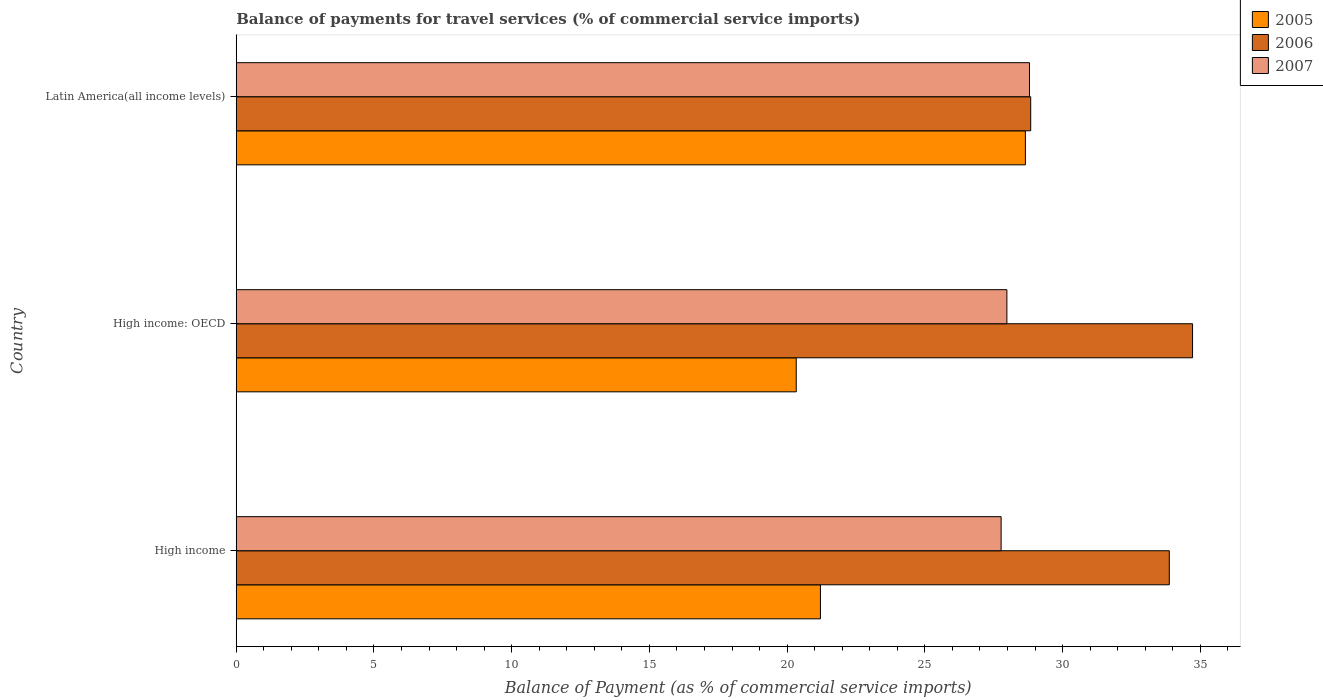How many different coloured bars are there?
Give a very brief answer. 3. How many bars are there on the 3rd tick from the top?
Offer a terse response. 3. How many bars are there on the 3rd tick from the bottom?
Offer a very short reply. 3. What is the label of the 1st group of bars from the top?
Offer a terse response. Latin America(all income levels). What is the balance of payments for travel services in 2006 in High income: OECD?
Ensure brevity in your answer.  34.72. Across all countries, what is the maximum balance of payments for travel services in 2007?
Your answer should be compact. 28.8. Across all countries, what is the minimum balance of payments for travel services in 2007?
Give a very brief answer. 27.77. In which country was the balance of payments for travel services in 2007 maximum?
Your answer should be very brief. Latin America(all income levels). In which country was the balance of payments for travel services in 2007 minimum?
Keep it short and to the point. High income. What is the total balance of payments for travel services in 2007 in the graph?
Keep it short and to the point. 84.55. What is the difference between the balance of payments for travel services in 2007 in High income: OECD and that in Latin America(all income levels)?
Provide a succinct answer. -0.82. What is the difference between the balance of payments for travel services in 2006 in High income and the balance of payments for travel services in 2005 in Latin America(all income levels)?
Keep it short and to the point. 5.23. What is the average balance of payments for travel services in 2006 per country?
Make the answer very short. 32.48. What is the difference between the balance of payments for travel services in 2005 and balance of payments for travel services in 2006 in High income?
Make the answer very short. -12.67. What is the ratio of the balance of payments for travel services in 2005 in High income: OECD to that in Latin America(all income levels)?
Offer a very short reply. 0.71. Is the difference between the balance of payments for travel services in 2005 in High income and Latin America(all income levels) greater than the difference between the balance of payments for travel services in 2006 in High income and Latin America(all income levels)?
Give a very brief answer. No. What is the difference between the highest and the second highest balance of payments for travel services in 2006?
Your response must be concise. 0.84. What is the difference between the highest and the lowest balance of payments for travel services in 2006?
Provide a succinct answer. 5.88. Is it the case that in every country, the sum of the balance of payments for travel services in 2006 and balance of payments for travel services in 2007 is greater than the balance of payments for travel services in 2005?
Ensure brevity in your answer.  Yes. Are the values on the major ticks of X-axis written in scientific E-notation?
Offer a very short reply. No. How many legend labels are there?
Offer a very short reply. 3. How are the legend labels stacked?
Ensure brevity in your answer.  Vertical. What is the title of the graph?
Your answer should be very brief. Balance of payments for travel services (% of commercial service imports). What is the label or title of the X-axis?
Offer a very short reply. Balance of Payment (as % of commercial service imports). What is the Balance of Payment (as % of commercial service imports) of 2005 in High income?
Your response must be concise. 21.21. What is the Balance of Payment (as % of commercial service imports) in 2006 in High income?
Your response must be concise. 33.88. What is the Balance of Payment (as % of commercial service imports) in 2007 in High income?
Your answer should be compact. 27.77. What is the Balance of Payment (as % of commercial service imports) in 2005 in High income: OECD?
Make the answer very short. 20.33. What is the Balance of Payment (as % of commercial service imports) in 2006 in High income: OECD?
Keep it short and to the point. 34.72. What is the Balance of Payment (as % of commercial service imports) of 2007 in High income: OECD?
Make the answer very short. 27.98. What is the Balance of Payment (as % of commercial service imports) in 2005 in Latin America(all income levels)?
Make the answer very short. 28.65. What is the Balance of Payment (as % of commercial service imports) of 2006 in Latin America(all income levels)?
Offer a terse response. 28.84. What is the Balance of Payment (as % of commercial service imports) of 2007 in Latin America(all income levels)?
Ensure brevity in your answer.  28.8. Across all countries, what is the maximum Balance of Payment (as % of commercial service imports) of 2005?
Your response must be concise. 28.65. Across all countries, what is the maximum Balance of Payment (as % of commercial service imports) in 2006?
Your answer should be very brief. 34.72. Across all countries, what is the maximum Balance of Payment (as % of commercial service imports) in 2007?
Your response must be concise. 28.8. Across all countries, what is the minimum Balance of Payment (as % of commercial service imports) in 2005?
Keep it short and to the point. 20.33. Across all countries, what is the minimum Balance of Payment (as % of commercial service imports) of 2006?
Offer a very short reply. 28.84. Across all countries, what is the minimum Balance of Payment (as % of commercial service imports) in 2007?
Your answer should be compact. 27.77. What is the total Balance of Payment (as % of commercial service imports) of 2005 in the graph?
Give a very brief answer. 70.19. What is the total Balance of Payment (as % of commercial service imports) of 2006 in the graph?
Your response must be concise. 97.44. What is the total Balance of Payment (as % of commercial service imports) of 2007 in the graph?
Offer a terse response. 84.55. What is the difference between the Balance of Payment (as % of commercial service imports) of 2005 in High income and that in High income: OECD?
Your answer should be very brief. 0.88. What is the difference between the Balance of Payment (as % of commercial service imports) of 2006 in High income and that in High income: OECD?
Give a very brief answer. -0.84. What is the difference between the Balance of Payment (as % of commercial service imports) of 2007 in High income and that in High income: OECD?
Give a very brief answer. -0.21. What is the difference between the Balance of Payment (as % of commercial service imports) of 2005 in High income and that in Latin America(all income levels)?
Your response must be concise. -7.44. What is the difference between the Balance of Payment (as % of commercial service imports) in 2006 in High income and that in Latin America(all income levels)?
Ensure brevity in your answer.  5.03. What is the difference between the Balance of Payment (as % of commercial service imports) in 2007 in High income and that in Latin America(all income levels)?
Your answer should be very brief. -1.03. What is the difference between the Balance of Payment (as % of commercial service imports) of 2005 in High income: OECD and that in Latin America(all income levels)?
Keep it short and to the point. -8.32. What is the difference between the Balance of Payment (as % of commercial service imports) of 2006 in High income: OECD and that in Latin America(all income levels)?
Give a very brief answer. 5.88. What is the difference between the Balance of Payment (as % of commercial service imports) in 2007 in High income: OECD and that in Latin America(all income levels)?
Ensure brevity in your answer.  -0.82. What is the difference between the Balance of Payment (as % of commercial service imports) in 2005 in High income and the Balance of Payment (as % of commercial service imports) in 2006 in High income: OECD?
Provide a succinct answer. -13.51. What is the difference between the Balance of Payment (as % of commercial service imports) of 2005 in High income and the Balance of Payment (as % of commercial service imports) of 2007 in High income: OECD?
Your response must be concise. -6.77. What is the difference between the Balance of Payment (as % of commercial service imports) in 2006 in High income and the Balance of Payment (as % of commercial service imports) in 2007 in High income: OECD?
Offer a very short reply. 5.9. What is the difference between the Balance of Payment (as % of commercial service imports) of 2005 in High income and the Balance of Payment (as % of commercial service imports) of 2006 in Latin America(all income levels)?
Make the answer very short. -7.63. What is the difference between the Balance of Payment (as % of commercial service imports) in 2005 in High income and the Balance of Payment (as % of commercial service imports) in 2007 in Latin America(all income levels)?
Your answer should be compact. -7.59. What is the difference between the Balance of Payment (as % of commercial service imports) in 2006 in High income and the Balance of Payment (as % of commercial service imports) in 2007 in Latin America(all income levels)?
Ensure brevity in your answer.  5.08. What is the difference between the Balance of Payment (as % of commercial service imports) of 2005 in High income: OECD and the Balance of Payment (as % of commercial service imports) of 2006 in Latin America(all income levels)?
Provide a short and direct response. -8.51. What is the difference between the Balance of Payment (as % of commercial service imports) of 2005 in High income: OECD and the Balance of Payment (as % of commercial service imports) of 2007 in Latin America(all income levels)?
Make the answer very short. -8.47. What is the difference between the Balance of Payment (as % of commercial service imports) of 2006 in High income: OECD and the Balance of Payment (as % of commercial service imports) of 2007 in Latin America(all income levels)?
Your response must be concise. 5.92. What is the average Balance of Payment (as % of commercial service imports) of 2005 per country?
Keep it short and to the point. 23.4. What is the average Balance of Payment (as % of commercial service imports) of 2006 per country?
Your response must be concise. 32.48. What is the average Balance of Payment (as % of commercial service imports) of 2007 per country?
Give a very brief answer. 28.18. What is the difference between the Balance of Payment (as % of commercial service imports) of 2005 and Balance of Payment (as % of commercial service imports) of 2006 in High income?
Your response must be concise. -12.67. What is the difference between the Balance of Payment (as % of commercial service imports) in 2005 and Balance of Payment (as % of commercial service imports) in 2007 in High income?
Give a very brief answer. -6.56. What is the difference between the Balance of Payment (as % of commercial service imports) of 2006 and Balance of Payment (as % of commercial service imports) of 2007 in High income?
Make the answer very short. 6.11. What is the difference between the Balance of Payment (as % of commercial service imports) in 2005 and Balance of Payment (as % of commercial service imports) in 2006 in High income: OECD?
Give a very brief answer. -14.39. What is the difference between the Balance of Payment (as % of commercial service imports) of 2005 and Balance of Payment (as % of commercial service imports) of 2007 in High income: OECD?
Offer a terse response. -7.65. What is the difference between the Balance of Payment (as % of commercial service imports) of 2006 and Balance of Payment (as % of commercial service imports) of 2007 in High income: OECD?
Your response must be concise. 6.74. What is the difference between the Balance of Payment (as % of commercial service imports) of 2005 and Balance of Payment (as % of commercial service imports) of 2006 in Latin America(all income levels)?
Offer a very short reply. -0.19. What is the difference between the Balance of Payment (as % of commercial service imports) in 2005 and Balance of Payment (as % of commercial service imports) in 2007 in Latin America(all income levels)?
Offer a very short reply. -0.15. What is the difference between the Balance of Payment (as % of commercial service imports) of 2006 and Balance of Payment (as % of commercial service imports) of 2007 in Latin America(all income levels)?
Provide a short and direct response. 0.04. What is the ratio of the Balance of Payment (as % of commercial service imports) of 2005 in High income to that in High income: OECD?
Make the answer very short. 1.04. What is the ratio of the Balance of Payment (as % of commercial service imports) in 2006 in High income to that in High income: OECD?
Offer a very short reply. 0.98. What is the ratio of the Balance of Payment (as % of commercial service imports) of 2007 in High income to that in High income: OECD?
Your response must be concise. 0.99. What is the ratio of the Balance of Payment (as % of commercial service imports) of 2005 in High income to that in Latin America(all income levels)?
Your response must be concise. 0.74. What is the ratio of the Balance of Payment (as % of commercial service imports) of 2006 in High income to that in Latin America(all income levels)?
Give a very brief answer. 1.17. What is the ratio of the Balance of Payment (as % of commercial service imports) of 2007 in High income to that in Latin America(all income levels)?
Your response must be concise. 0.96. What is the ratio of the Balance of Payment (as % of commercial service imports) of 2005 in High income: OECD to that in Latin America(all income levels)?
Your answer should be very brief. 0.71. What is the ratio of the Balance of Payment (as % of commercial service imports) of 2006 in High income: OECD to that in Latin America(all income levels)?
Make the answer very short. 1.2. What is the ratio of the Balance of Payment (as % of commercial service imports) in 2007 in High income: OECD to that in Latin America(all income levels)?
Offer a terse response. 0.97. What is the difference between the highest and the second highest Balance of Payment (as % of commercial service imports) in 2005?
Your answer should be very brief. 7.44. What is the difference between the highest and the second highest Balance of Payment (as % of commercial service imports) in 2006?
Offer a terse response. 0.84. What is the difference between the highest and the second highest Balance of Payment (as % of commercial service imports) in 2007?
Keep it short and to the point. 0.82. What is the difference between the highest and the lowest Balance of Payment (as % of commercial service imports) in 2005?
Ensure brevity in your answer.  8.32. What is the difference between the highest and the lowest Balance of Payment (as % of commercial service imports) in 2006?
Keep it short and to the point. 5.88. What is the difference between the highest and the lowest Balance of Payment (as % of commercial service imports) of 2007?
Offer a very short reply. 1.03. 